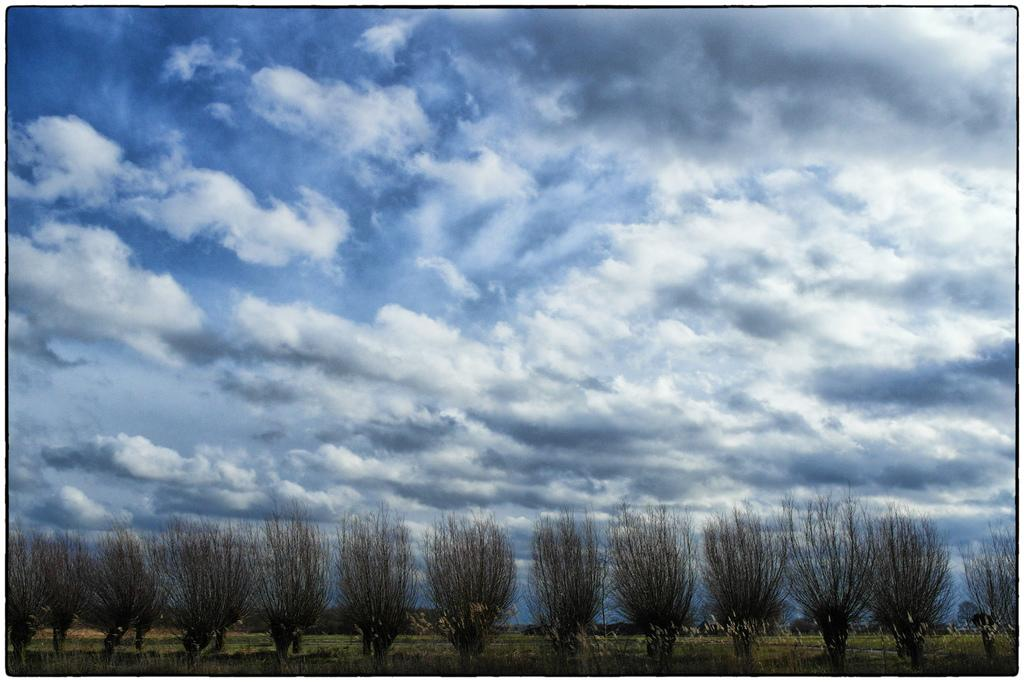What can be seen in the sky in the image? There are many clouds in the sky in the image. What is located at the bottom of the image? There are plants at the bottom of the image. What type of vegetation is present on the ground in the image? There is green grass on the ground in the image. What type of border is visible around the plants in the image? There is no border visible around the plants in the image. Is there a doll playing with the plants in the image? There is no doll present in the image. 